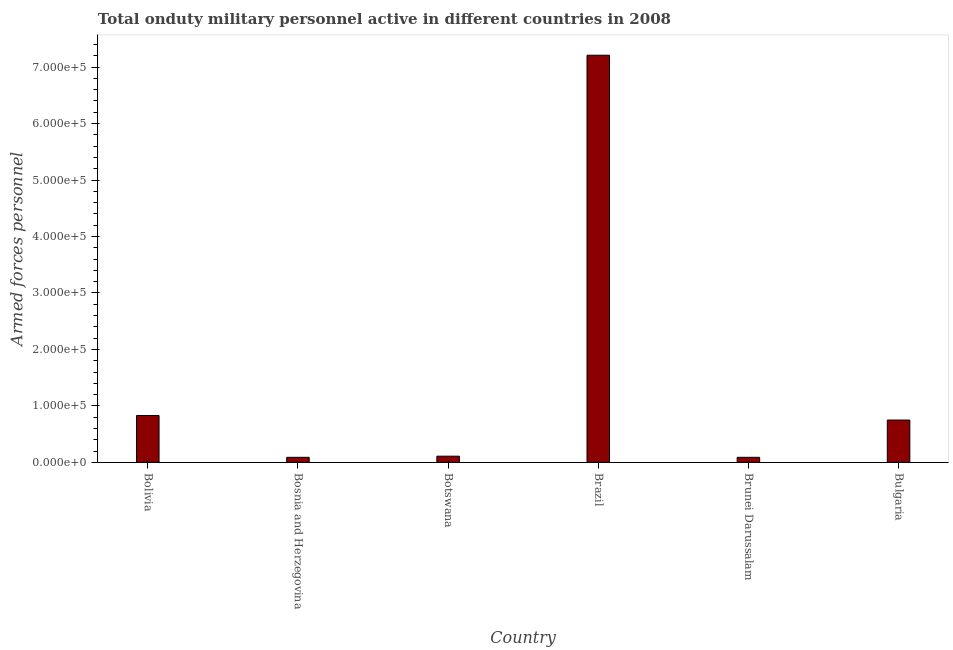What is the title of the graph?
Offer a terse response. Total onduty military personnel active in different countries in 2008. What is the label or title of the Y-axis?
Keep it short and to the point. Armed forces personnel. What is the number of armed forces personnel in Bulgaria?
Offer a terse response. 7.50e+04. Across all countries, what is the maximum number of armed forces personnel?
Keep it short and to the point. 7.21e+05. Across all countries, what is the minimum number of armed forces personnel?
Ensure brevity in your answer.  9000. In which country was the number of armed forces personnel minimum?
Offer a very short reply. Bosnia and Herzegovina. What is the sum of the number of armed forces personnel?
Offer a terse response. 9.08e+05. What is the difference between the number of armed forces personnel in Botswana and Bulgaria?
Provide a short and direct response. -6.40e+04. What is the average number of armed forces personnel per country?
Keep it short and to the point. 1.51e+05. What is the median number of armed forces personnel?
Keep it short and to the point. 4.30e+04. In how many countries, is the number of armed forces personnel greater than 180000 ?
Make the answer very short. 1. What is the ratio of the number of armed forces personnel in Bosnia and Herzegovina to that in Brazil?
Give a very brief answer. 0.01. Is the difference between the number of armed forces personnel in Bolivia and Brunei Darussalam greater than the difference between any two countries?
Your answer should be very brief. No. What is the difference between the highest and the second highest number of armed forces personnel?
Your answer should be very brief. 6.38e+05. What is the difference between the highest and the lowest number of armed forces personnel?
Make the answer very short. 7.12e+05. How many bars are there?
Your response must be concise. 6. Are all the bars in the graph horizontal?
Your response must be concise. No. How many countries are there in the graph?
Provide a short and direct response. 6. What is the Armed forces personnel in Bolivia?
Your answer should be very brief. 8.30e+04. What is the Armed forces personnel in Bosnia and Herzegovina?
Your answer should be very brief. 9000. What is the Armed forces personnel of Botswana?
Ensure brevity in your answer.  1.10e+04. What is the Armed forces personnel of Brazil?
Offer a terse response. 7.21e+05. What is the Armed forces personnel of Brunei Darussalam?
Your answer should be very brief. 9000. What is the Armed forces personnel in Bulgaria?
Provide a succinct answer. 7.50e+04. What is the difference between the Armed forces personnel in Bolivia and Bosnia and Herzegovina?
Offer a very short reply. 7.40e+04. What is the difference between the Armed forces personnel in Bolivia and Botswana?
Provide a short and direct response. 7.20e+04. What is the difference between the Armed forces personnel in Bolivia and Brazil?
Give a very brief answer. -6.38e+05. What is the difference between the Armed forces personnel in Bolivia and Brunei Darussalam?
Offer a very short reply. 7.40e+04. What is the difference between the Armed forces personnel in Bolivia and Bulgaria?
Your answer should be compact. 8000. What is the difference between the Armed forces personnel in Bosnia and Herzegovina and Botswana?
Ensure brevity in your answer.  -2000. What is the difference between the Armed forces personnel in Bosnia and Herzegovina and Brazil?
Keep it short and to the point. -7.12e+05. What is the difference between the Armed forces personnel in Bosnia and Herzegovina and Bulgaria?
Provide a succinct answer. -6.60e+04. What is the difference between the Armed forces personnel in Botswana and Brazil?
Ensure brevity in your answer.  -7.10e+05. What is the difference between the Armed forces personnel in Botswana and Brunei Darussalam?
Keep it short and to the point. 2000. What is the difference between the Armed forces personnel in Botswana and Bulgaria?
Your answer should be compact. -6.40e+04. What is the difference between the Armed forces personnel in Brazil and Brunei Darussalam?
Your answer should be very brief. 7.12e+05. What is the difference between the Armed forces personnel in Brazil and Bulgaria?
Your answer should be compact. 6.46e+05. What is the difference between the Armed forces personnel in Brunei Darussalam and Bulgaria?
Give a very brief answer. -6.60e+04. What is the ratio of the Armed forces personnel in Bolivia to that in Bosnia and Herzegovina?
Your response must be concise. 9.22. What is the ratio of the Armed forces personnel in Bolivia to that in Botswana?
Keep it short and to the point. 7.54. What is the ratio of the Armed forces personnel in Bolivia to that in Brazil?
Make the answer very short. 0.12. What is the ratio of the Armed forces personnel in Bolivia to that in Brunei Darussalam?
Give a very brief answer. 9.22. What is the ratio of the Armed forces personnel in Bolivia to that in Bulgaria?
Provide a short and direct response. 1.11. What is the ratio of the Armed forces personnel in Bosnia and Herzegovina to that in Botswana?
Your answer should be very brief. 0.82. What is the ratio of the Armed forces personnel in Bosnia and Herzegovina to that in Brazil?
Offer a terse response. 0.01. What is the ratio of the Armed forces personnel in Bosnia and Herzegovina to that in Bulgaria?
Your answer should be compact. 0.12. What is the ratio of the Armed forces personnel in Botswana to that in Brazil?
Provide a short and direct response. 0.01. What is the ratio of the Armed forces personnel in Botswana to that in Brunei Darussalam?
Ensure brevity in your answer.  1.22. What is the ratio of the Armed forces personnel in Botswana to that in Bulgaria?
Your answer should be compact. 0.15. What is the ratio of the Armed forces personnel in Brazil to that in Brunei Darussalam?
Keep it short and to the point. 80.11. What is the ratio of the Armed forces personnel in Brazil to that in Bulgaria?
Ensure brevity in your answer.  9.61. What is the ratio of the Armed forces personnel in Brunei Darussalam to that in Bulgaria?
Ensure brevity in your answer.  0.12. 